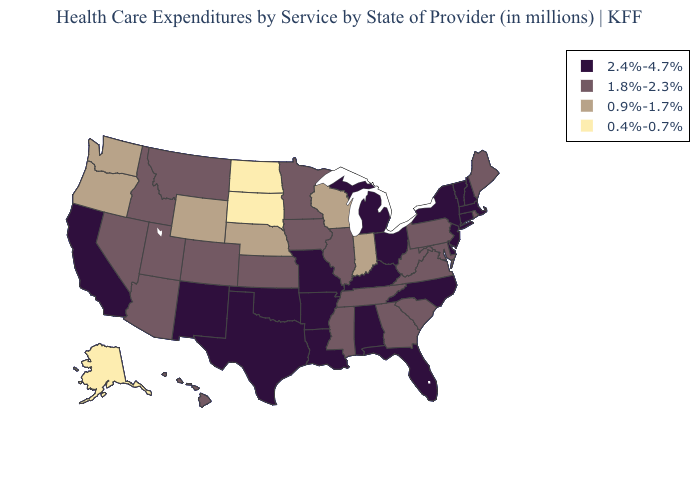What is the lowest value in the USA?
Short answer required. 0.4%-0.7%. What is the value of California?
Write a very short answer. 2.4%-4.7%. What is the value of Arizona?
Be succinct. 1.8%-2.3%. What is the lowest value in the USA?
Quick response, please. 0.4%-0.7%. What is the lowest value in states that border Mississippi?
Short answer required. 1.8%-2.3%. What is the value of Tennessee?
Short answer required. 1.8%-2.3%. What is the value of Maine?
Quick response, please. 1.8%-2.3%. Does New Mexico have the lowest value in the USA?
Keep it brief. No. Name the states that have a value in the range 0.9%-1.7%?
Keep it brief. Indiana, Nebraska, Oregon, Washington, Wisconsin, Wyoming. What is the value of Maine?
Short answer required. 1.8%-2.3%. Which states have the lowest value in the USA?
Short answer required. Alaska, North Dakota, South Dakota. Among the states that border Missouri , which have the highest value?
Answer briefly. Arkansas, Kentucky, Oklahoma. Is the legend a continuous bar?
Concise answer only. No. Among the states that border Indiana , which have the lowest value?
Give a very brief answer. Illinois. 